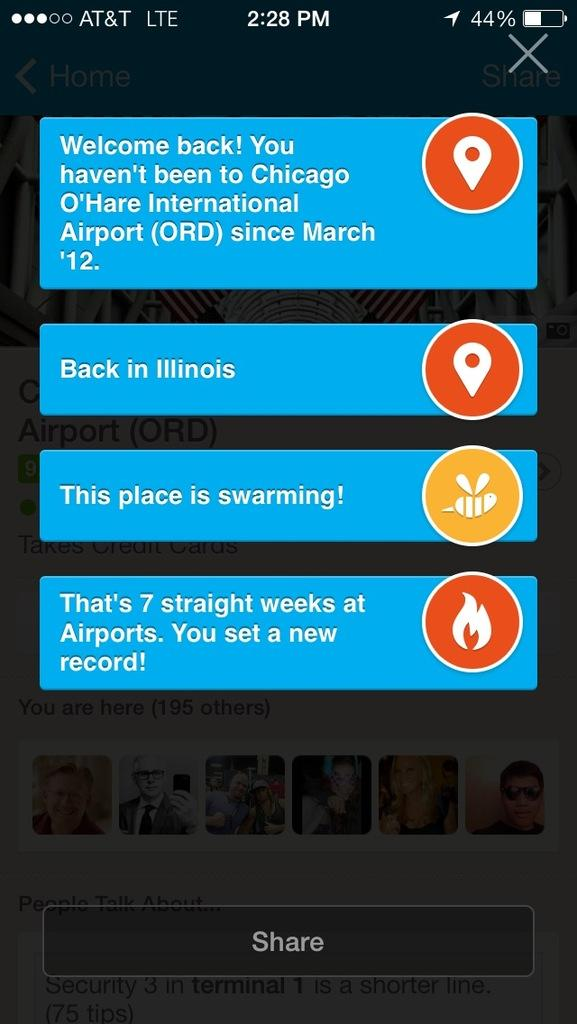<image>
Write a terse but informative summary of the picture. A screen shot of a phone that is connected to AT&T. 